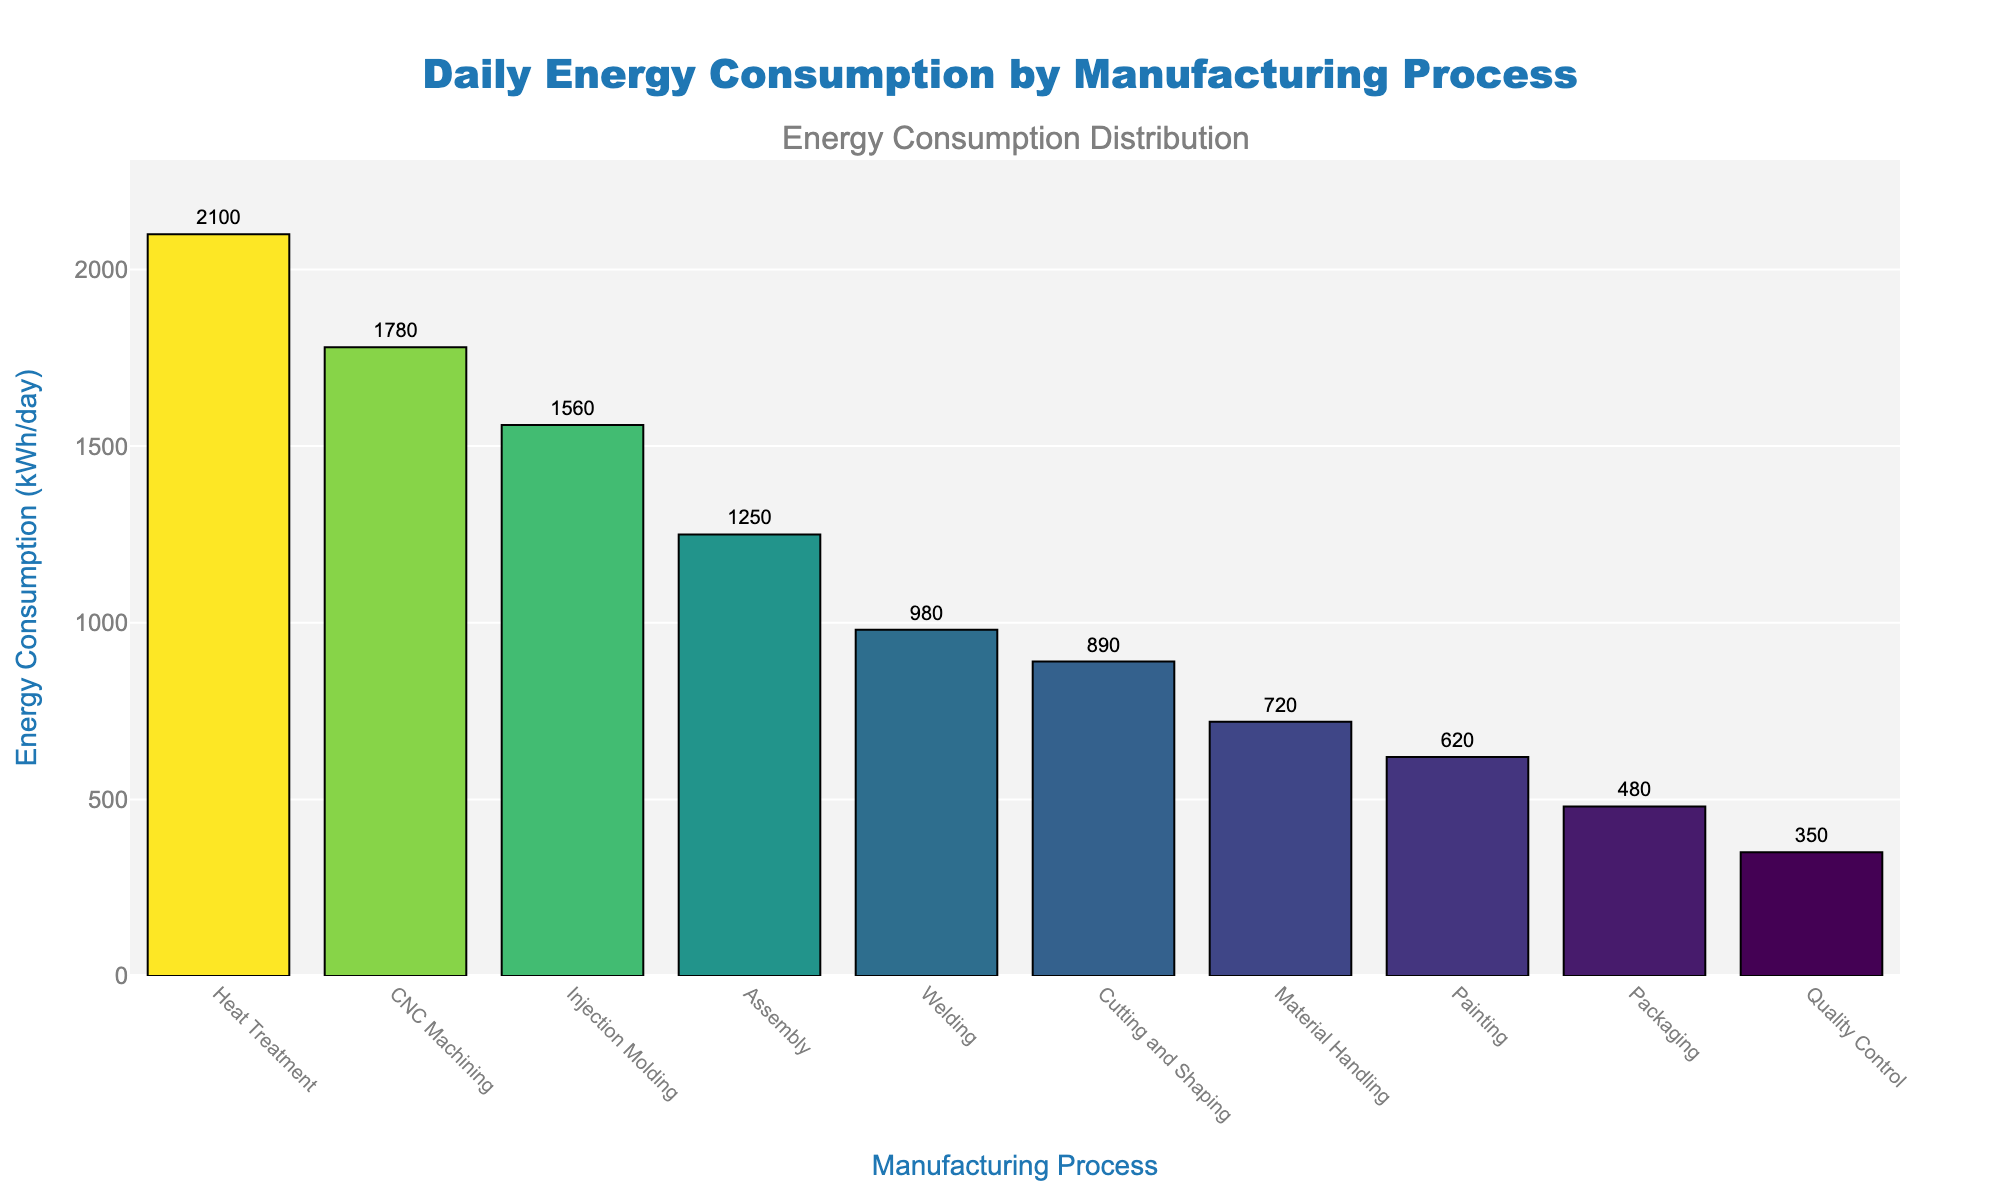Which manufacturing process consumes the most energy daily? The bar corresponding to the highest energy consumption has the highest length. Heat Treatment is the highest bar.
Answer: Heat Treatment Which manufacturing process consumes the least energy daily? The bar corresponding to the lowest energy consumption has the shortest length. Quality Control is the shortest bar.
Answer: Quality Control What is the difference in energy consumption between Heat Treatment and Painting? The energy consumption of Heat Treatment is 2100 kWh/day, and for Painting, it is 620 kWh/day. The difference is 2100 - 620 = 1480 kWh/day.
Answer: 1480 kWh/day Which processes consume more than 1000 kWh/day? The bars that extend beyond the 1000 kWh/day mark represent these processes. These are Heat Treatment (2100), CNC Machining (1780), Injection Molding (1560), Assembly (1250), and Welding (980).
Answer: Heat Treatment, CNC Machining, Injection Molding, Assembly, Welding How much combined energy is consumed by Injection Molding, Cutting and Shaping, and Packaging? Add the energy consumption of Injection Molding (1560 kWh/day), Cutting and Shaping (890 kWh/day), and Packaging (480 kWh/day). 1560 + 890 + 480 = 2930 kWh/day.
Answer: 2930 kWh/day Is the energy consumption of Welding greater than or less than Material Handling? Welding has an energy consumption of 980 kWh/day, while Material Handling has 720 kWh/day. 980 is greater than 720.
Answer: Greater What is the combined energy consumption of the three lowest-consuming processes? Add the energy consumption of Quality Control (350 kWh/day), Packaging (480 kWh/day), and Painting (620 kWh/day). 350 + 480 + 620 = 1450 kWh/day.
Answer: 1450 kWh/day How does the energy consumption of CNC Machining compare to Assembly? CNC Machining has an energy consumption of 1780 kWh/day, and Assembly has 1250 kWh/day. 1780 is greater than 1250.
Answer: CNC Machining has higher consumption Which manufacturing processes consume less than 500 kWh/day? The bars that do not extend beyond the 500 kWh/day mark represent these processes. Quality Control (350) and Packaging (480).
Answer: Quality Control, Packaging 